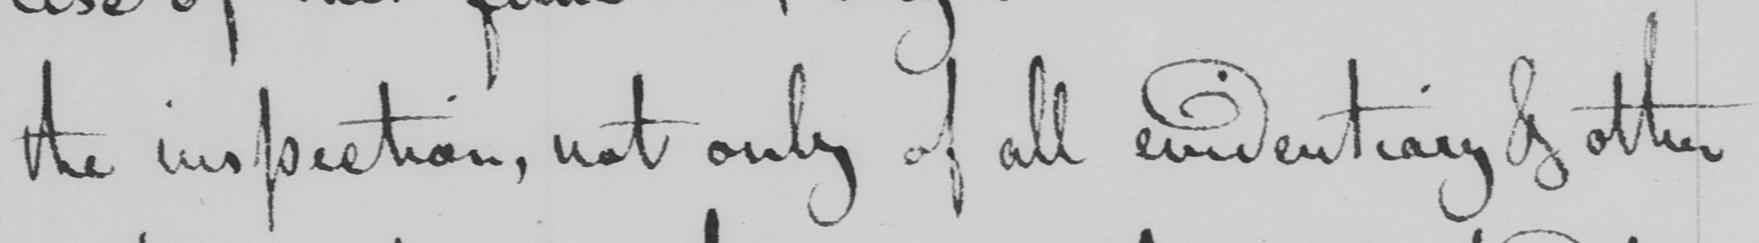What does this handwritten line say? the inspection , not only of all evidentiary & other 